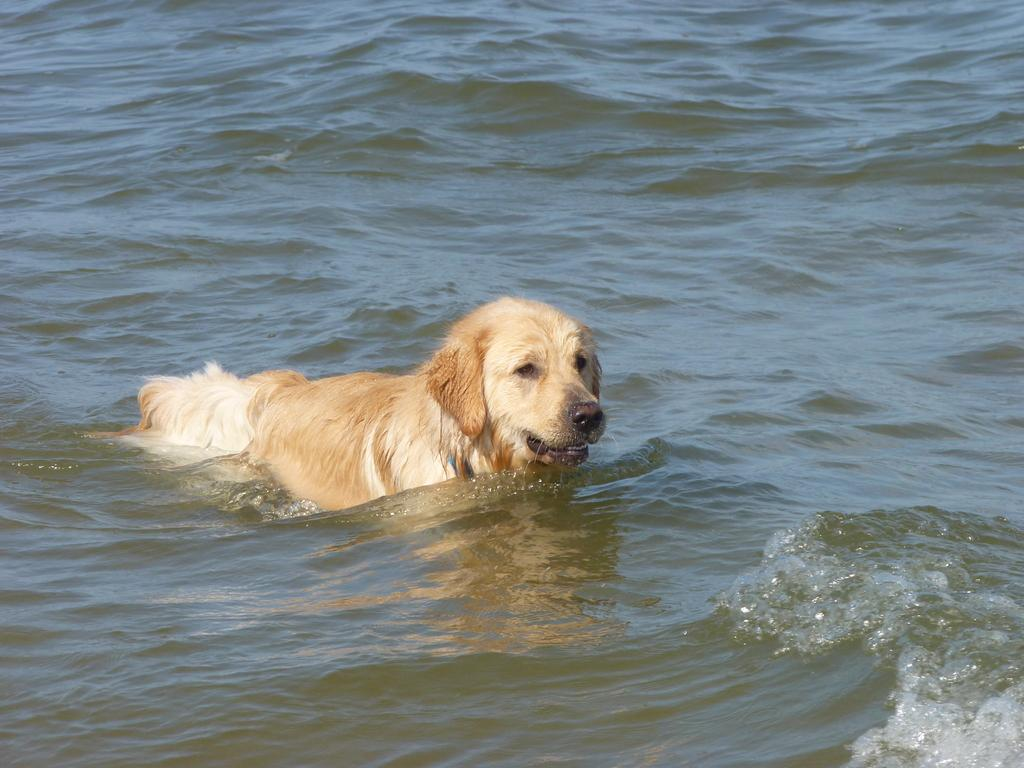What type of animal is in the image? There is a dog in the image. Where is the dog located in the image? The dog is in the water. What type of vase can be seen in the image? There is no vase present in the image; it features a dog in the water. 